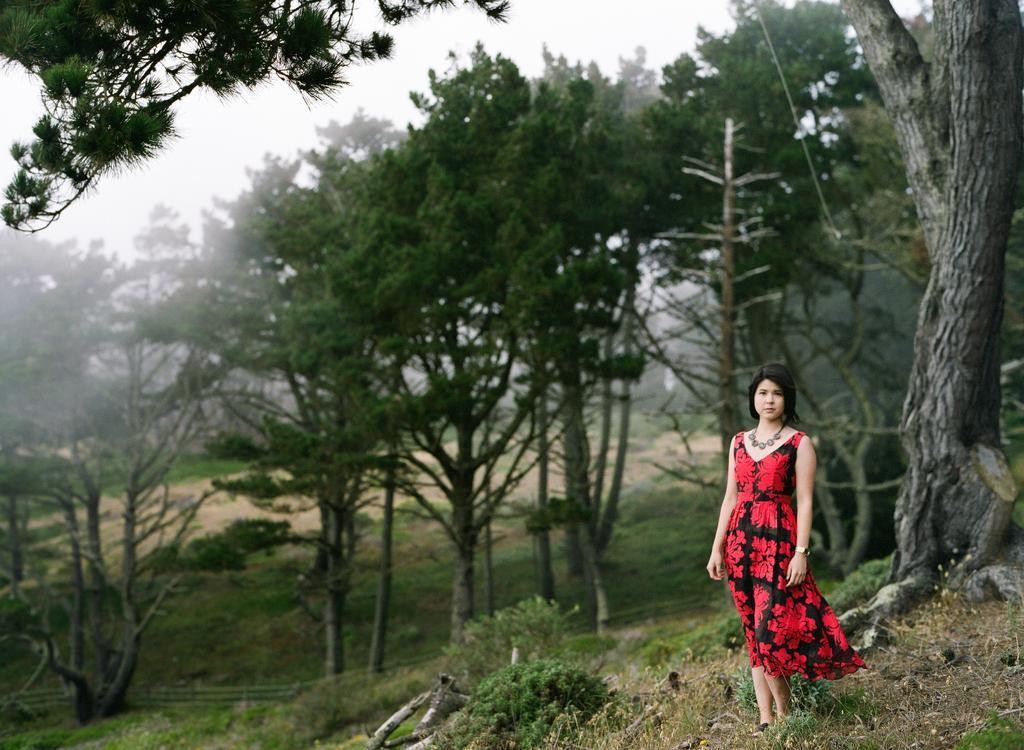Describe this image in one or two sentences. On the right side of this image there is a woman wearing a red color dress, standing on the ground and giving pose for the picture. At the bottom there are many plants and sticks on the ground. In the background there are many trees. At the top of the image I can see the sky. 